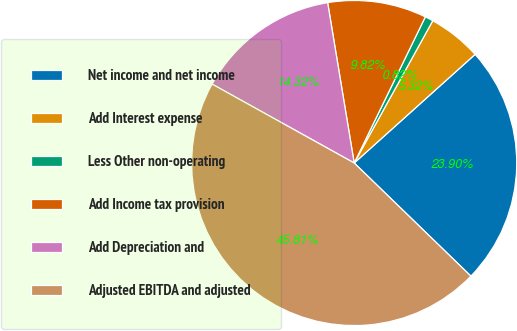Convert chart to OTSL. <chart><loc_0><loc_0><loc_500><loc_500><pie_chart><fcel>Net income and net income<fcel>Add Interest expense<fcel>Less Other non-operating<fcel>Add Income tax provision<fcel>Add Depreciation and<fcel>Adjusted EBITDA and adjusted<nl><fcel>23.9%<fcel>5.32%<fcel>0.82%<fcel>9.82%<fcel>14.32%<fcel>45.81%<nl></chart> 